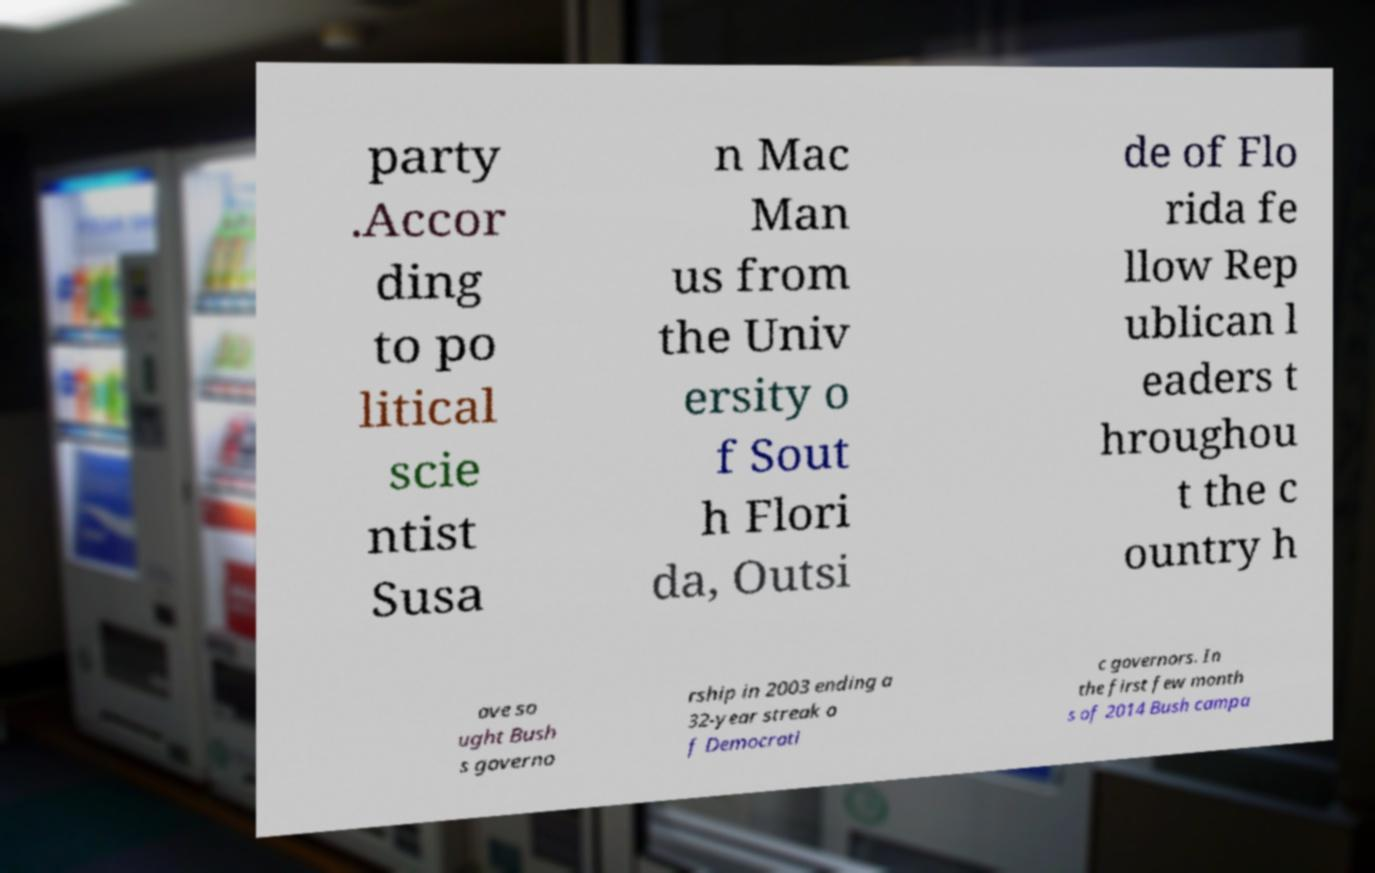For documentation purposes, I need the text within this image transcribed. Could you provide that? party .Accor ding to po litical scie ntist Susa n Mac Man us from the Univ ersity o f Sout h Flori da, Outsi de of Flo rida fe llow Rep ublican l eaders t hroughou t the c ountry h ave so ught Bush s governo rship in 2003 ending a 32-year streak o f Democrati c governors. In the first few month s of 2014 Bush campa 